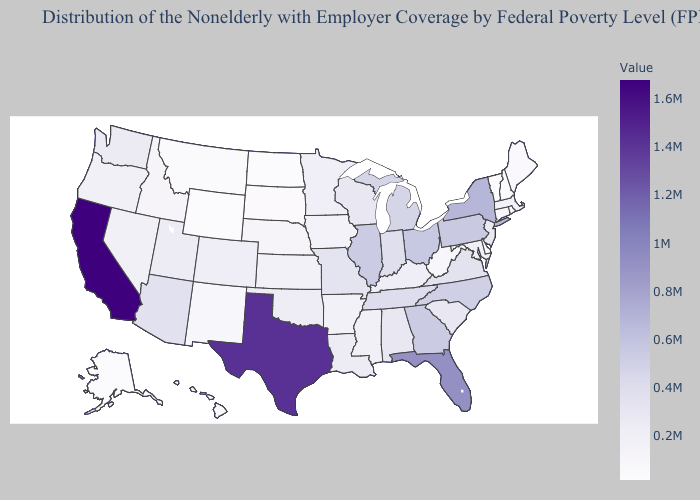Does Vermont have the lowest value in the Northeast?
Write a very short answer. Yes. Which states have the lowest value in the MidWest?
Answer briefly. North Dakota. Which states have the lowest value in the Northeast?
Be succinct. Vermont. Does the map have missing data?
Keep it brief. No. Among the states that border Montana , does North Dakota have the lowest value?
Quick response, please. Yes. Does Virginia have the lowest value in the USA?
Concise answer only. No. 